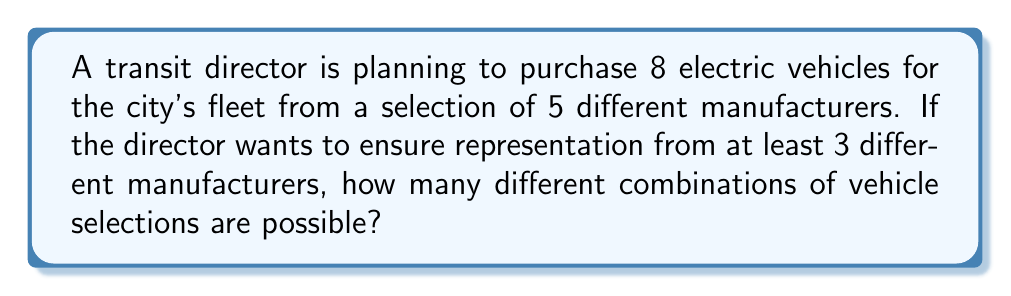Help me with this question. Let's approach this step-by-step:

1) First, we need to consider the total number of ways to select 8 vehicles from 5 manufacturers, ensuring at least 3 manufacturers are represented.

2) We can solve this by subtracting the number of combinations that use only 1 or 2 manufacturers from the total number of combinations.

3) Total number of combinations (without restrictions):
   $$\binom{5+8-1}{8} = \binom{12}{8} = 495$$

4) Number of combinations using only 1 manufacturer:
   $$\binom{5}{1} = 5$$

5) Number of combinations using only 2 manufacturers:
   We need to select 2 manufacturers out of 5, and then distribute 8 vehicles between them:
   $$\binom{5}{2} \cdot \binom{8+2-1}{8-1} = 10 \cdot 9 = 90$$

6) Therefore, the number of combinations using at least 3 manufacturers is:
   $$495 - 5 - 90 = 400$$

This calculation ensures that we have counted all possible combinations that include at least 3 different manufacturers.
Answer: 400 combinations 